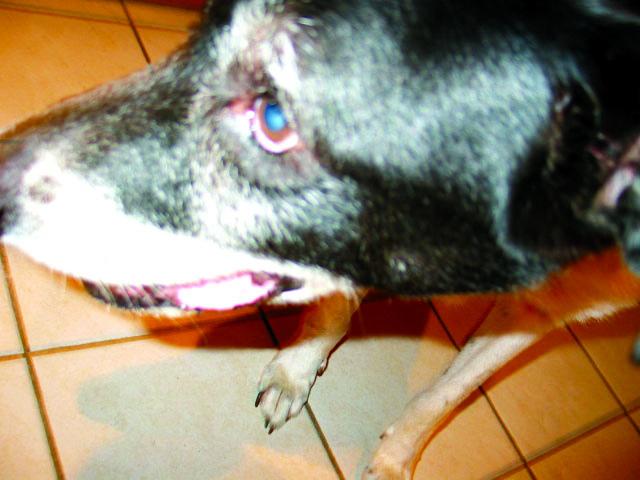What color is the dog?
Concise answer only. Black. What kind of animal is in the picture?
Short answer required. Dog. What is the dog laying on?
Be succinct. Floor. 